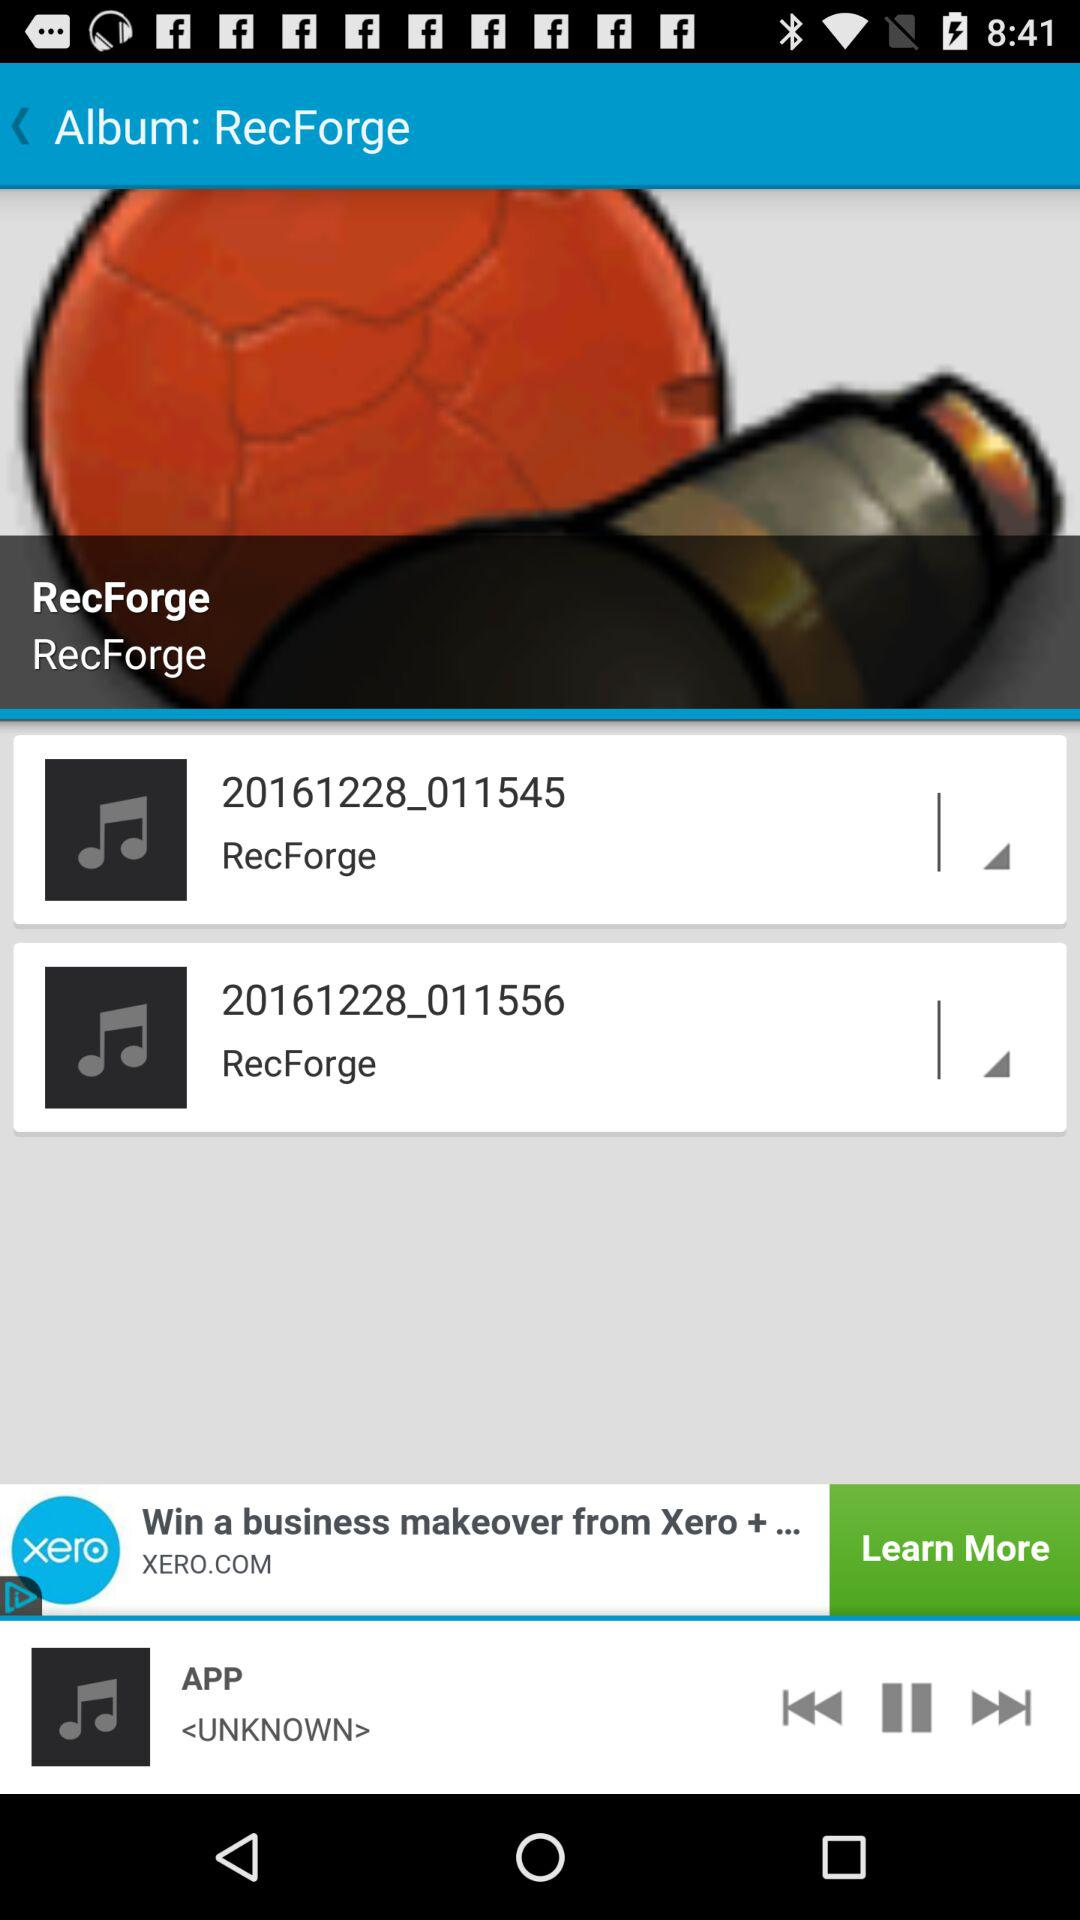What is the name of the album? The name of the album is "RecForge". 